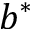Convert formula to latex. <formula><loc_0><loc_0><loc_500><loc_500>b ^ { * }</formula> 